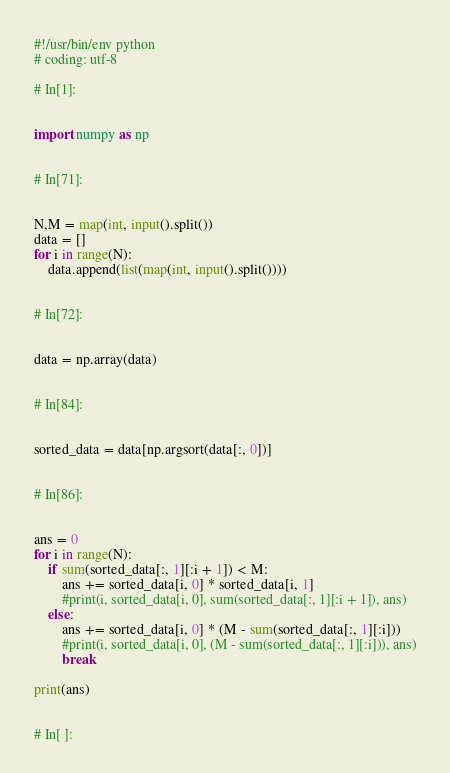Convert code to text. <code><loc_0><loc_0><loc_500><loc_500><_Python_>#!/usr/bin/env python
# coding: utf-8

# In[1]:


import numpy as np


# In[71]:


N,M = map(int, input().split())
data = []
for i in range(N):
    data.append(list(map(int, input().split())))


# In[72]:


data = np.array(data)


# In[84]:


sorted_data = data[np.argsort(data[:, 0])]


# In[86]:


ans = 0
for i in range(N):
    if sum(sorted_data[:, 1][:i + 1]) < M:
        ans += sorted_data[i, 0] * sorted_data[i, 1]
        #print(i, sorted_data[i, 0], sum(sorted_data[:, 1][:i + 1]), ans)
    else:
        ans += sorted_data[i, 0] * (M - sum(sorted_data[:, 1][:i]))
        #print(i, sorted_data[i, 0], (M - sum(sorted_data[:, 1][:i])), ans)
        break

print(ans)


# In[ ]:




</code> 